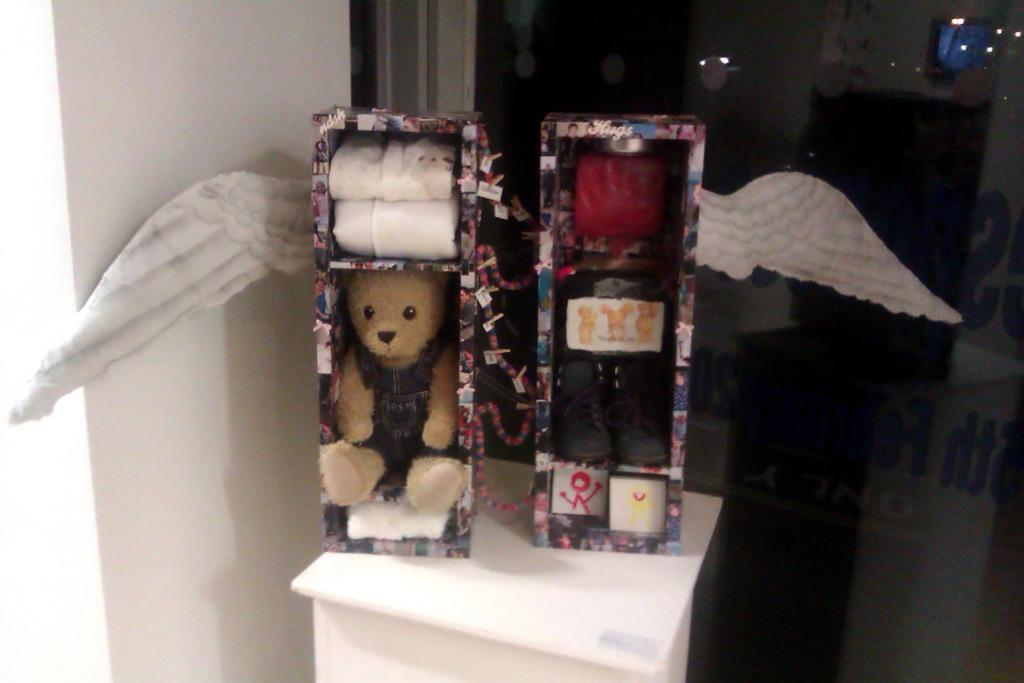What is inside the box on the left side of the image? There is a teddy inside a box on the left side of the image. What is inside the box on the right side of the image? There are shoes inside a box on the right side of the image. How many boats are visible in the image? There are no boats present in the image. What type of picture is hanging on the wall in the image? There is no picture hanging on the wall in the image. 